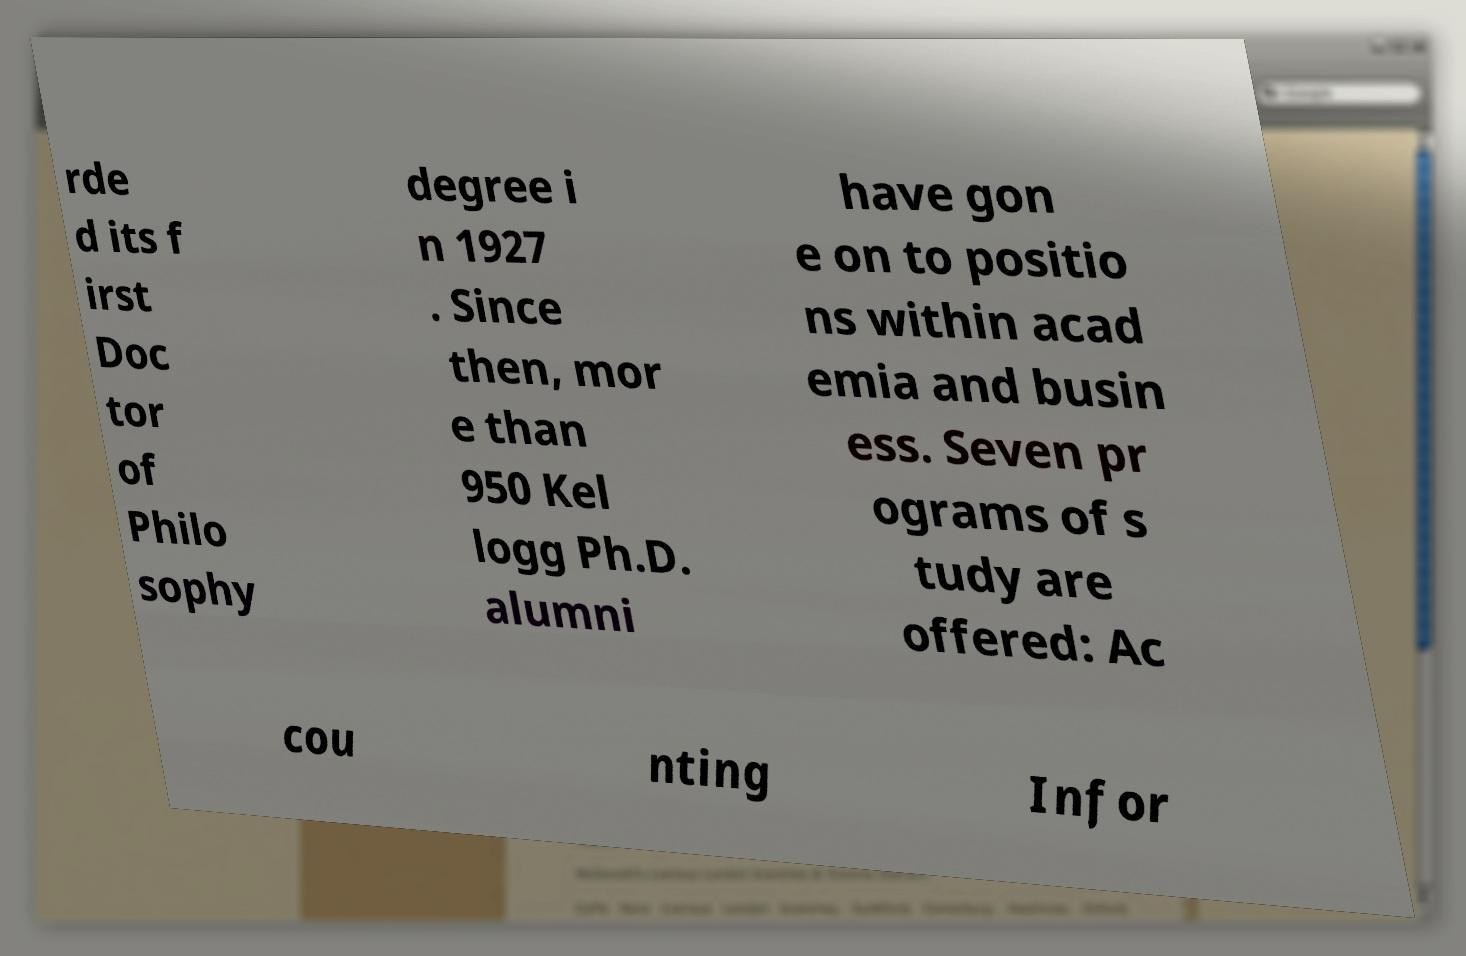Please read and relay the text visible in this image. What does it say? rde d its f irst Doc tor of Philo sophy degree i n 1927 . Since then, mor e than 950 Kel logg Ph.D. alumni have gon e on to positio ns within acad emia and busin ess. Seven pr ograms of s tudy are offered: Ac cou nting Infor 